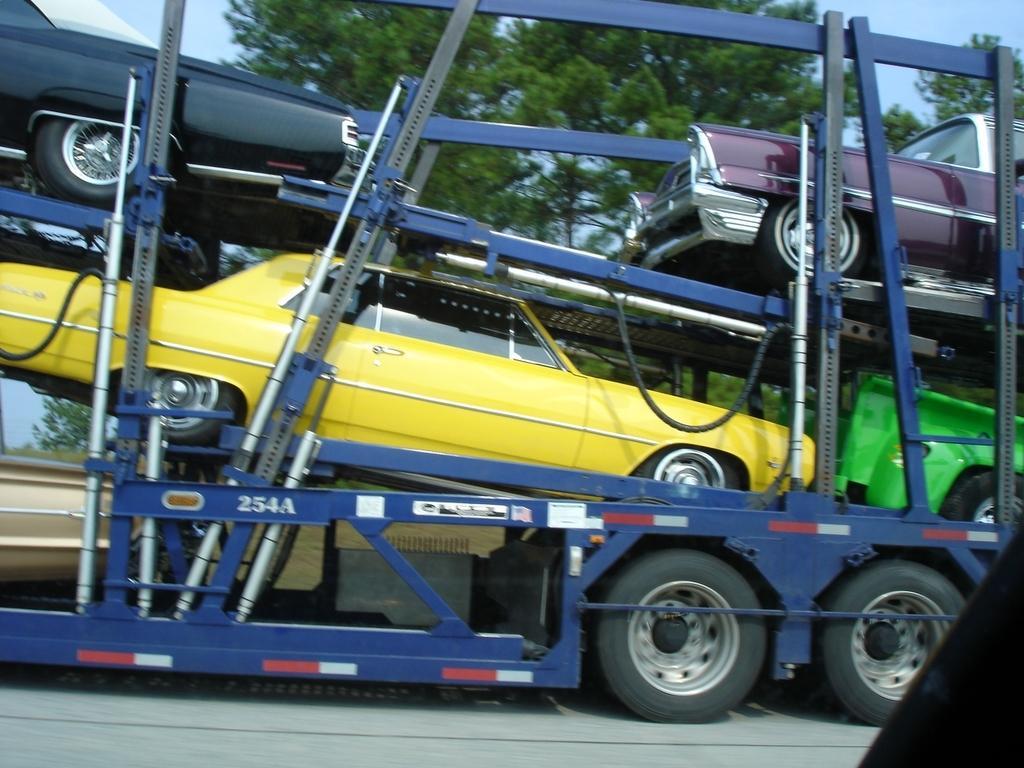Please provide a concise description of this image. In this image there are few cars transported in a truck. In the background there are trees. 